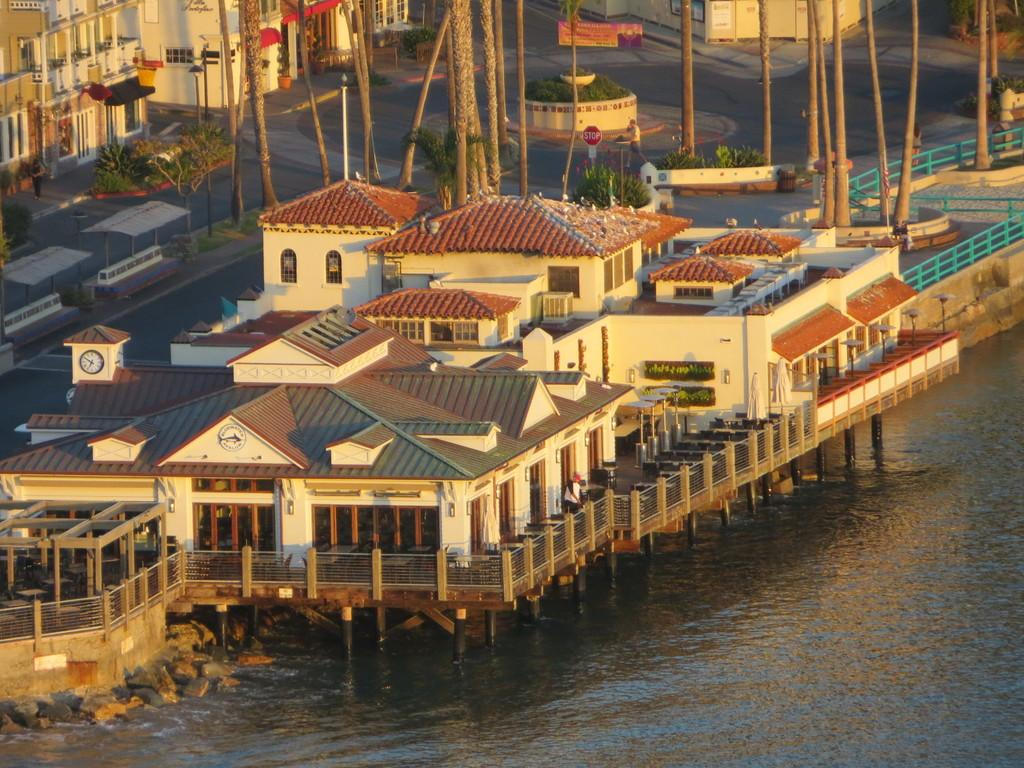What type of structures can be seen in the image? There are houses in the image. What other natural elements are present in the image? There are trees in the image. What man-made objects can be seen along the road in the image? There are sign boards on the road in the image. Can you describe the activity of the person in the image? There is a person walking in the image. What can be seen in front of the houses? There is water visible in front of the houses. Where is the calendar located in the image? There is no calendar present in the image. What type of shelf can be seen in the image? There is no shelf present in the image. 